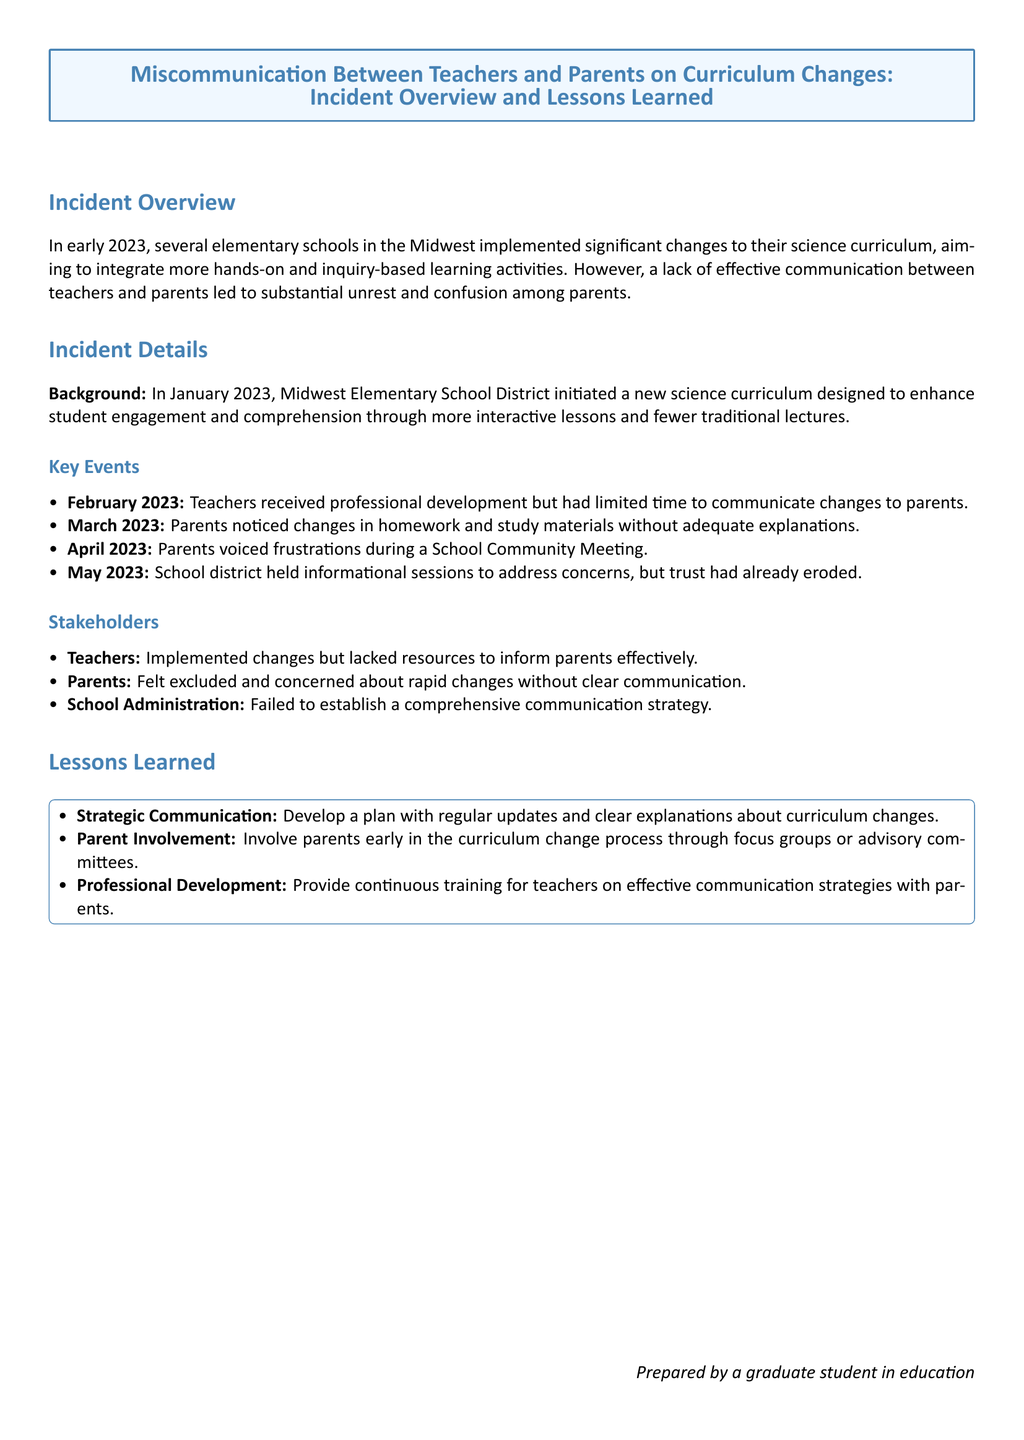What year did the curriculum changes occur? The document states that the changes were implemented in early 2023.
Answer: 2023 What month did parents initially notice changes? According to the timeline, parents noticed changes in March 2023.
Answer: March 2023 What type of learning activities were integrated into the curriculum? The overview mentions the integration of hands-on and inquiry-based learning activities.
Answer: Hands-on and inquiry-based learning activities Who were the main stakeholders mentioned? The document lists teachers, parents, and school administration as key stakeholders involved in the incident.
Answer: Teachers, parents, school administration What is one lesson learned regarding communication? The report emphasizes the importance of developing a strategic communication plan for updates and explanations.
Answer: Strategic Communication How did parents feel about the communication regarding changes? The document indicates that parents felt excluded and concerned about the changes without clear communication.
Answer: Excluded and concerned What month did the school district hold informational sessions? Informational sessions were held in May 2023 to address parents' concerns.
Answer: May 2023 What was a factor contributing to the erosion of trust? The lack of effective communication between teachers and parents was a key factor in eroding trust.
Answer: Lack of effective communication What did the teachers lack that hindered communication with parents? The incident report states that teachers lacked resources to inform parents effectively.
Answer: Resources to inform parents 